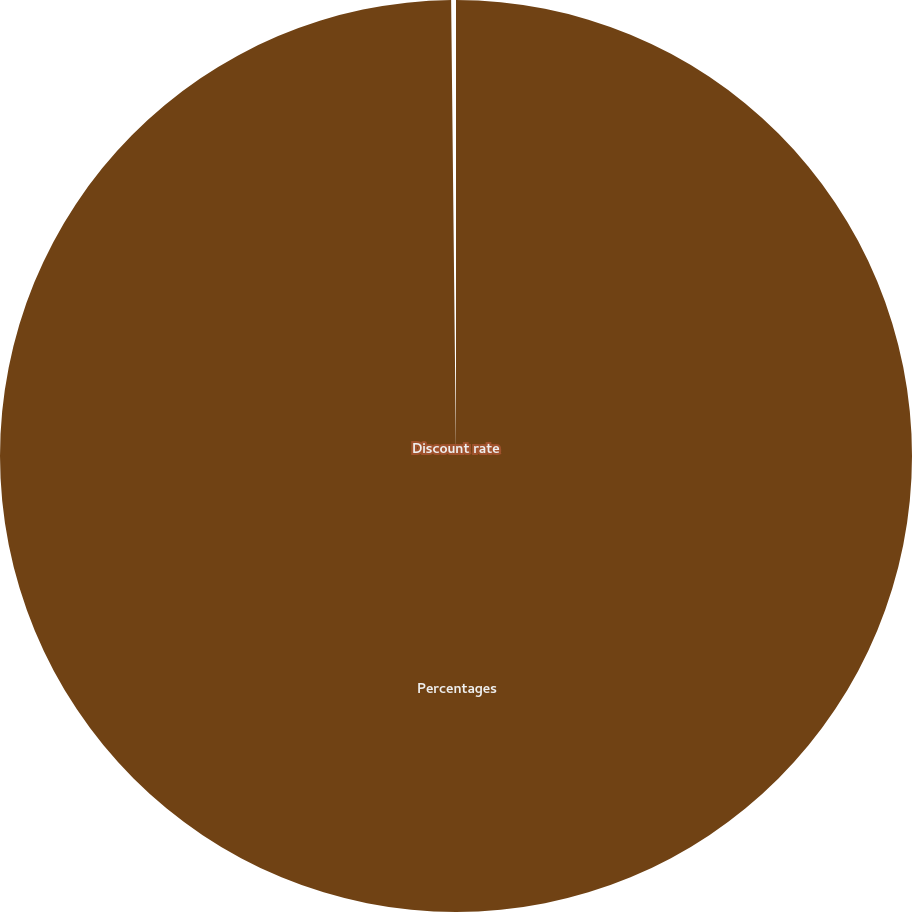Convert chart. <chart><loc_0><loc_0><loc_500><loc_500><pie_chart><fcel>Percentages<fcel>Discount rate<nl><fcel>99.83%<fcel>0.17%<nl></chart> 